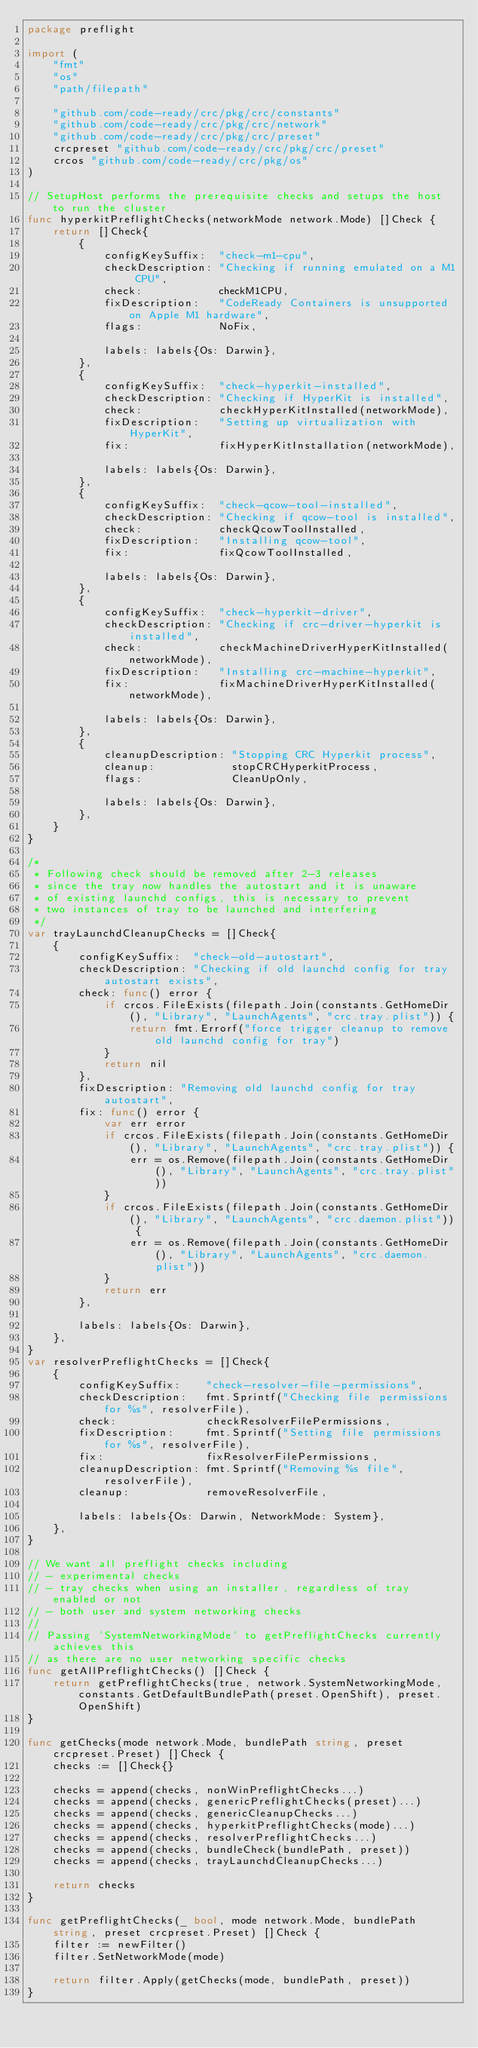<code> <loc_0><loc_0><loc_500><loc_500><_Go_>package preflight

import (
	"fmt"
	"os"
	"path/filepath"

	"github.com/code-ready/crc/pkg/crc/constants"
	"github.com/code-ready/crc/pkg/crc/network"
	"github.com/code-ready/crc/pkg/crc/preset"
	crcpreset "github.com/code-ready/crc/pkg/crc/preset"
	crcos "github.com/code-ready/crc/pkg/os"
)

// SetupHost performs the prerequisite checks and setups the host to run the cluster
func hyperkitPreflightChecks(networkMode network.Mode) []Check {
	return []Check{
		{
			configKeySuffix:  "check-m1-cpu",
			checkDescription: "Checking if running emulated on a M1 CPU",
			check:            checkM1CPU,
			fixDescription:   "CodeReady Containers is unsupported on Apple M1 hardware",
			flags:            NoFix,

			labels: labels{Os: Darwin},
		},
		{
			configKeySuffix:  "check-hyperkit-installed",
			checkDescription: "Checking if HyperKit is installed",
			check:            checkHyperKitInstalled(networkMode),
			fixDescription:   "Setting up virtualization with HyperKit",
			fix:              fixHyperKitInstallation(networkMode),

			labels: labels{Os: Darwin},
		},
		{
			configKeySuffix:  "check-qcow-tool-installed",
			checkDescription: "Checking if qcow-tool is installed",
			check:            checkQcowToolInstalled,
			fixDescription:   "Installing qcow-tool",
			fix:              fixQcowToolInstalled,

			labels: labels{Os: Darwin},
		},
		{
			configKeySuffix:  "check-hyperkit-driver",
			checkDescription: "Checking if crc-driver-hyperkit is installed",
			check:            checkMachineDriverHyperKitInstalled(networkMode),
			fixDescription:   "Installing crc-machine-hyperkit",
			fix:              fixMachineDriverHyperKitInstalled(networkMode),

			labels: labels{Os: Darwin},
		},
		{
			cleanupDescription: "Stopping CRC Hyperkit process",
			cleanup:            stopCRCHyperkitProcess,
			flags:              CleanUpOnly,

			labels: labels{Os: Darwin},
		},
	}
}

/*
 * Following check should be removed after 2-3 releases
 * since the tray now handles the autostart and it is unaware
 * of existing launchd configs, this is necessary to prevent
 * two instances of tray to be launched and interfering
 */
var trayLaunchdCleanupChecks = []Check{
	{
		configKeySuffix:  "check-old-autostart",
		checkDescription: "Checking if old launchd config for tray autostart exists",
		check: func() error {
			if crcos.FileExists(filepath.Join(constants.GetHomeDir(), "Library", "LaunchAgents", "crc.tray.plist")) {
				return fmt.Errorf("force trigger cleanup to remove old launchd config for tray")
			}
			return nil
		},
		fixDescription: "Removing old launchd config for tray autostart",
		fix: func() error {
			var err error
			if crcos.FileExists(filepath.Join(constants.GetHomeDir(), "Library", "LaunchAgents", "crc.tray.plist")) {
				err = os.Remove(filepath.Join(constants.GetHomeDir(), "Library", "LaunchAgents", "crc.tray.plist"))
			}
			if crcos.FileExists(filepath.Join(constants.GetHomeDir(), "Library", "LaunchAgents", "crc.daemon.plist")) {
				err = os.Remove(filepath.Join(constants.GetHomeDir(), "Library", "LaunchAgents", "crc.daemon.plist"))
			}
			return err
		},

		labels: labels{Os: Darwin},
	},
}
var resolverPreflightChecks = []Check{
	{
		configKeySuffix:    "check-resolver-file-permissions",
		checkDescription:   fmt.Sprintf("Checking file permissions for %s", resolverFile),
		check:              checkResolverFilePermissions,
		fixDescription:     fmt.Sprintf("Setting file permissions for %s", resolverFile),
		fix:                fixResolverFilePermissions,
		cleanupDescription: fmt.Sprintf("Removing %s file", resolverFile),
		cleanup:            removeResolverFile,

		labels: labels{Os: Darwin, NetworkMode: System},
	},
}

// We want all preflight checks including
// - experimental checks
// - tray checks when using an installer, regardless of tray enabled or not
// - both user and system networking checks
//
// Passing 'SystemNetworkingMode' to getPreflightChecks currently achieves this
// as there are no user networking specific checks
func getAllPreflightChecks() []Check {
	return getPreflightChecks(true, network.SystemNetworkingMode, constants.GetDefaultBundlePath(preset.OpenShift), preset.OpenShift)
}

func getChecks(mode network.Mode, bundlePath string, preset crcpreset.Preset) []Check {
	checks := []Check{}

	checks = append(checks, nonWinPreflightChecks...)
	checks = append(checks, genericPreflightChecks(preset)...)
	checks = append(checks, genericCleanupChecks...)
	checks = append(checks, hyperkitPreflightChecks(mode)...)
	checks = append(checks, resolverPreflightChecks...)
	checks = append(checks, bundleCheck(bundlePath, preset))
	checks = append(checks, trayLaunchdCleanupChecks...)

	return checks
}

func getPreflightChecks(_ bool, mode network.Mode, bundlePath string, preset crcpreset.Preset) []Check {
	filter := newFilter()
	filter.SetNetworkMode(mode)

	return filter.Apply(getChecks(mode, bundlePath, preset))
}
</code> 